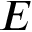<formula> <loc_0><loc_0><loc_500><loc_500>E</formula> 